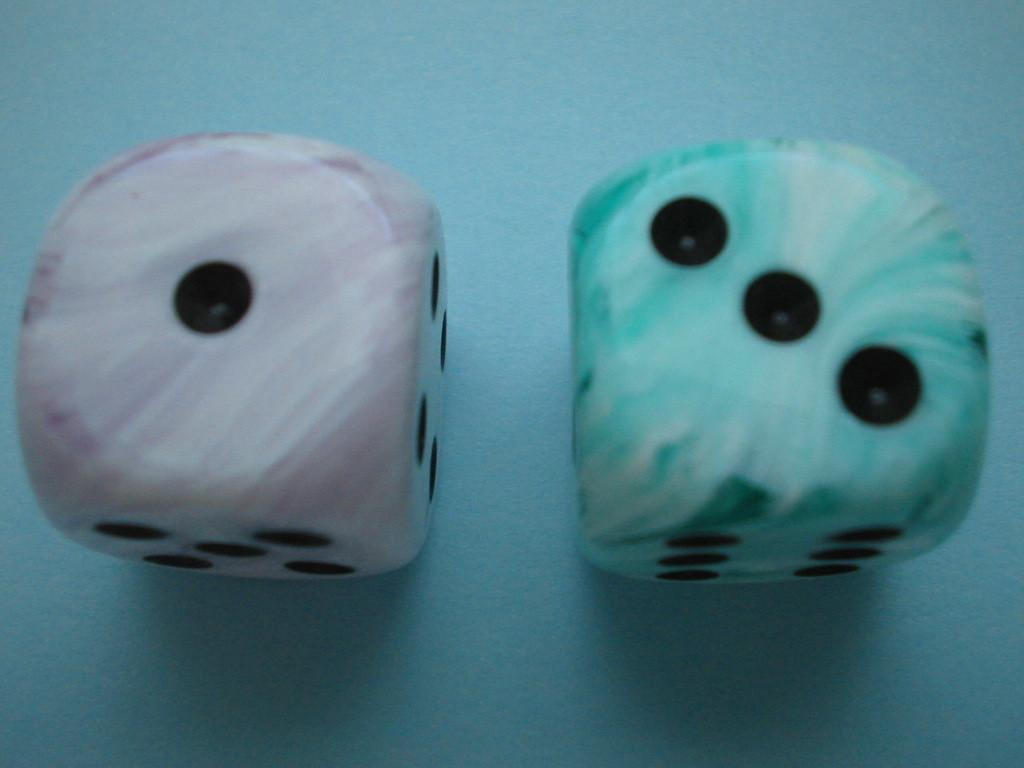What objects are present in the image? There are two dice in the image. What colors are the dice? One die is blue in color, and the other die is pink in color. What type of jewel is the bear wearing on its neck in the image? There are no bears or jewels present in the image; it only features two dice. 